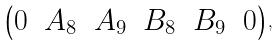<formula> <loc_0><loc_0><loc_500><loc_500>\begin{pmatrix} 0 & A _ { 8 } & A _ { 9 } & B _ { 8 } & B _ { 9 } & 0 \end{pmatrix} ,</formula> 